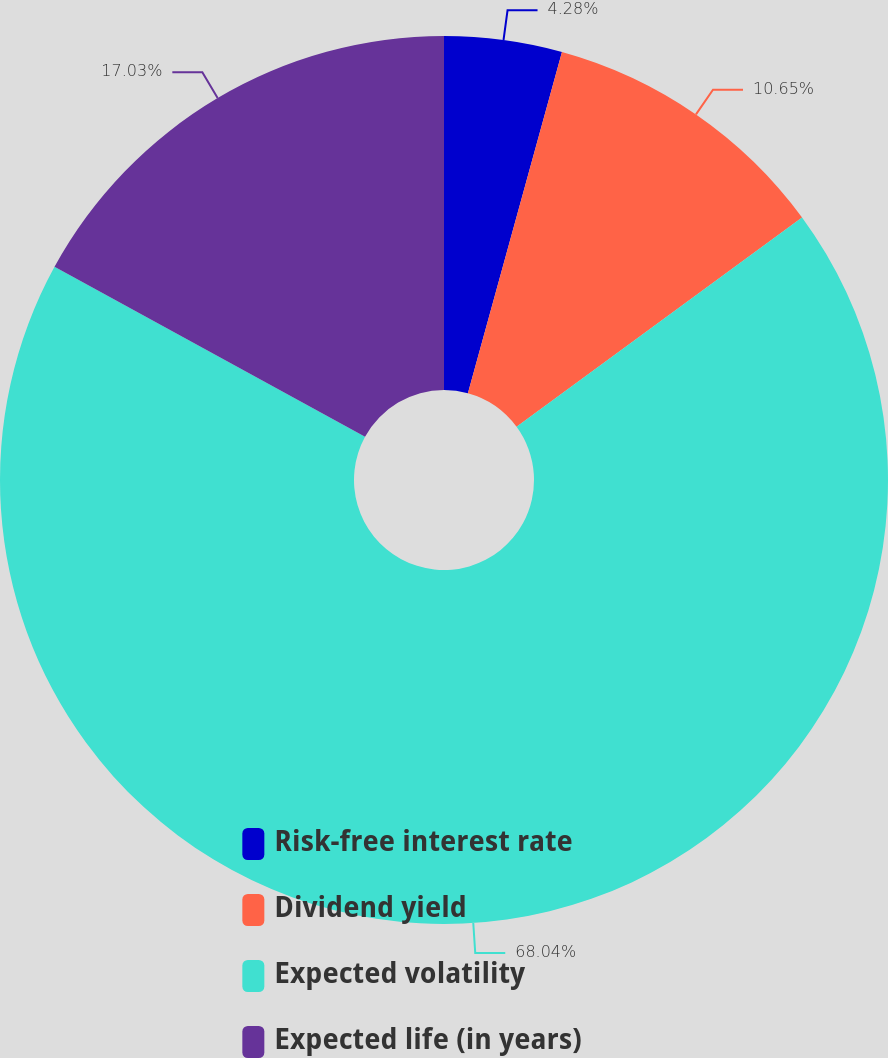Convert chart. <chart><loc_0><loc_0><loc_500><loc_500><pie_chart><fcel>Risk-free interest rate<fcel>Dividend yield<fcel>Expected volatility<fcel>Expected life (in years)<nl><fcel>4.28%<fcel>10.65%<fcel>68.04%<fcel>17.03%<nl></chart> 